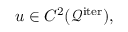<formula> <loc_0><loc_0><loc_500><loc_500>u \in C ^ { 2 } ( \mathcal { Q } ^ { i t e r } ) ,</formula> 